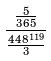<formula> <loc_0><loc_0><loc_500><loc_500>\frac { \frac { 5 } { 3 6 5 } } { \frac { 4 4 8 ^ { 1 1 9 } } { 3 } }</formula> 